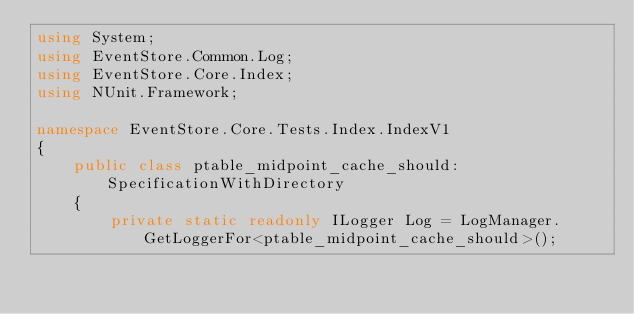Convert code to text. <code><loc_0><loc_0><loc_500><loc_500><_C#_>using System;
using EventStore.Common.Log;
using EventStore.Core.Index;
using NUnit.Framework;

namespace EventStore.Core.Tests.Index.IndexV1
{
    public class ptable_midpoint_cache_should: SpecificationWithDirectory
    {
        private static readonly ILogger Log = LogManager.GetLoggerFor<ptable_midpoint_cache_should>();</code> 